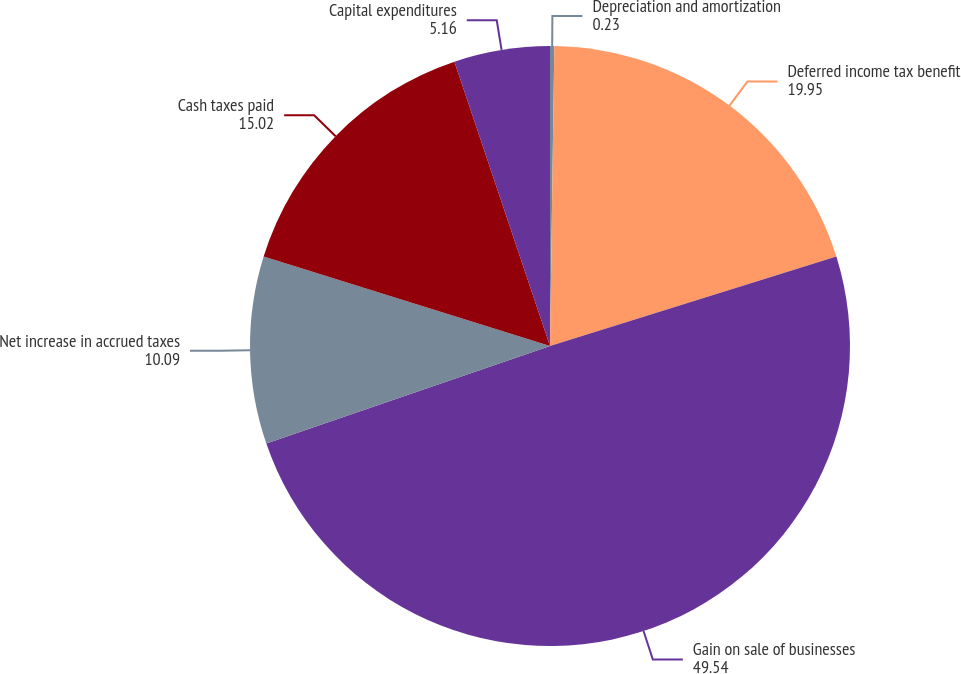Convert chart to OTSL. <chart><loc_0><loc_0><loc_500><loc_500><pie_chart><fcel>Depreciation and amortization<fcel>Deferred income tax benefit<fcel>Gain on sale of businesses<fcel>Net increase in accrued taxes<fcel>Cash taxes paid<fcel>Capital expenditures<nl><fcel>0.23%<fcel>19.95%<fcel>49.54%<fcel>10.09%<fcel>15.02%<fcel>5.16%<nl></chart> 